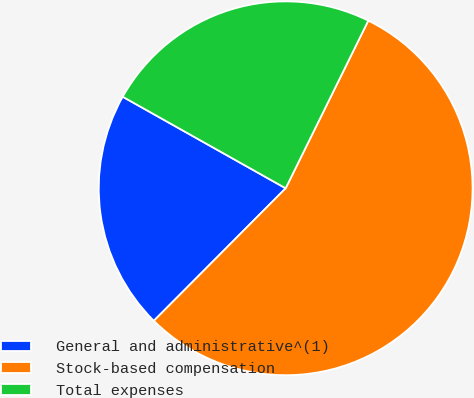Convert chart. <chart><loc_0><loc_0><loc_500><loc_500><pie_chart><fcel>General and administrative^(1)<fcel>Stock-based compensation<fcel>Total expenses<nl><fcel>20.69%<fcel>55.17%<fcel>24.14%<nl></chart> 